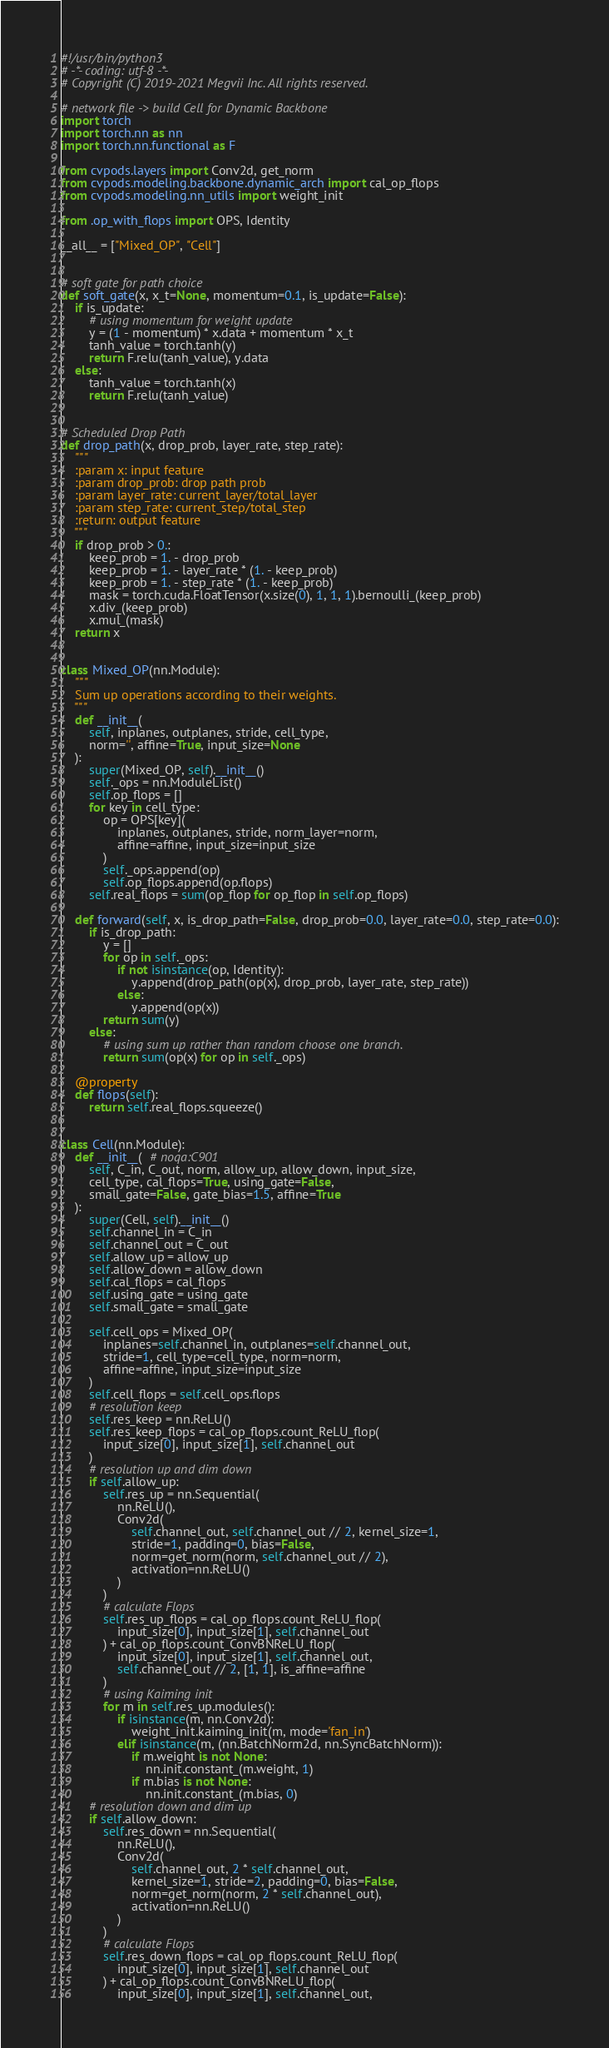Convert code to text. <code><loc_0><loc_0><loc_500><loc_500><_Python_>#!/usr/bin/python3
# -*- coding: utf-8 -*-
# Copyright (C) 2019-2021 Megvii Inc. All rights reserved.

# network file -> build Cell for Dynamic Backbone
import torch
import torch.nn as nn
import torch.nn.functional as F

from cvpods.layers import Conv2d, get_norm
from cvpods.modeling.backbone.dynamic_arch import cal_op_flops
from cvpods.modeling.nn_utils import weight_init

from .op_with_flops import OPS, Identity

__all__ = ["Mixed_OP", "Cell"]


# soft gate for path choice
def soft_gate(x, x_t=None, momentum=0.1, is_update=False):
    if is_update:
        # using momentum for weight update
        y = (1 - momentum) * x.data + momentum * x_t
        tanh_value = torch.tanh(y)
        return F.relu(tanh_value), y.data
    else:
        tanh_value = torch.tanh(x)
        return F.relu(tanh_value)


# Scheduled Drop Path
def drop_path(x, drop_prob, layer_rate, step_rate):
    """
    :param x: input feature
    :param drop_prob: drop path prob
    :param layer_rate: current_layer/total_layer
    :param step_rate: current_step/total_step
    :return: output feature
    """
    if drop_prob > 0.:
        keep_prob = 1. - drop_prob
        keep_prob = 1. - layer_rate * (1. - keep_prob)
        keep_prob = 1. - step_rate * (1. - keep_prob)
        mask = torch.cuda.FloatTensor(x.size(0), 1, 1, 1).bernoulli_(keep_prob)
        x.div_(keep_prob)
        x.mul_(mask)
    return x


class Mixed_OP(nn.Module):
    """
    Sum up operations according to their weights.
    """
    def __init__(
        self, inplanes, outplanes, stride, cell_type,
        norm='', affine=True, input_size=None
    ):
        super(Mixed_OP, self).__init__()
        self._ops = nn.ModuleList()
        self.op_flops = []
        for key in cell_type:
            op = OPS[key](
                inplanes, outplanes, stride, norm_layer=norm,
                affine=affine, input_size=input_size
            )
            self._ops.append(op)
            self.op_flops.append(op.flops)
        self.real_flops = sum(op_flop for op_flop in self.op_flops)

    def forward(self, x, is_drop_path=False, drop_prob=0.0, layer_rate=0.0, step_rate=0.0):
        if is_drop_path:
            y = []
            for op in self._ops:
                if not isinstance(op, Identity):
                    y.append(drop_path(op(x), drop_prob, layer_rate, step_rate))
                else:
                    y.append(op(x))
            return sum(y)
        else:
            # using sum up rather than random choose one branch.
            return sum(op(x) for op in self._ops)

    @property
    def flops(self):
        return self.real_flops.squeeze()


class Cell(nn.Module):
    def __init__(  # noqa:C901
        self, C_in, C_out, norm, allow_up, allow_down, input_size,
        cell_type, cal_flops=True, using_gate=False,
        small_gate=False, gate_bias=1.5, affine=True
    ):
        super(Cell, self).__init__()
        self.channel_in = C_in
        self.channel_out = C_out
        self.allow_up = allow_up
        self.allow_down = allow_down
        self.cal_flops = cal_flops
        self.using_gate = using_gate
        self.small_gate = small_gate

        self.cell_ops = Mixed_OP(
            inplanes=self.channel_in, outplanes=self.channel_out,
            stride=1, cell_type=cell_type, norm=norm,
            affine=affine, input_size=input_size
        )
        self.cell_flops = self.cell_ops.flops
        # resolution keep
        self.res_keep = nn.ReLU()
        self.res_keep_flops = cal_op_flops.count_ReLU_flop(
            input_size[0], input_size[1], self.channel_out
        )
        # resolution up and dim down
        if self.allow_up:
            self.res_up = nn.Sequential(
                nn.ReLU(),
                Conv2d(
                    self.channel_out, self.channel_out // 2, kernel_size=1,
                    stride=1, padding=0, bias=False,
                    norm=get_norm(norm, self.channel_out // 2),
                    activation=nn.ReLU()
                )
            )
            # calculate Flops
            self.res_up_flops = cal_op_flops.count_ReLU_flop(
                input_size[0], input_size[1], self.channel_out
            ) + cal_op_flops.count_ConvBNReLU_flop(
                input_size[0], input_size[1], self.channel_out,
                self.channel_out // 2, [1, 1], is_affine=affine
            )
            # using Kaiming init
            for m in self.res_up.modules():
                if isinstance(m, nn.Conv2d):
                    weight_init.kaiming_init(m, mode='fan_in')
                elif isinstance(m, (nn.BatchNorm2d, nn.SyncBatchNorm)):
                    if m.weight is not None:
                        nn.init.constant_(m.weight, 1)
                    if m.bias is not None:
                        nn.init.constant_(m.bias, 0)
        # resolution down and dim up
        if self.allow_down:
            self.res_down = nn.Sequential(
                nn.ReLU(),
                Conv2d(
                    self.channel_out, 2 * self.channel_out,
                    kernel_size=1, stride=2, padding=0, bias=False,
                    norm=get_norm(norm, 2 * self.channel_out),
                    activation=nn.ReLU()
                )
            )
            # calculate Flops
            self.res_down_flops = cal_op_flops.count_ReLU_flop(
                input_size[0], input_size[1], self.channel_out
            ) + cal_op_flops.count_ConvBNReLU_flop(
                input_size[0], input_size[1], self.channel_out,</code> 